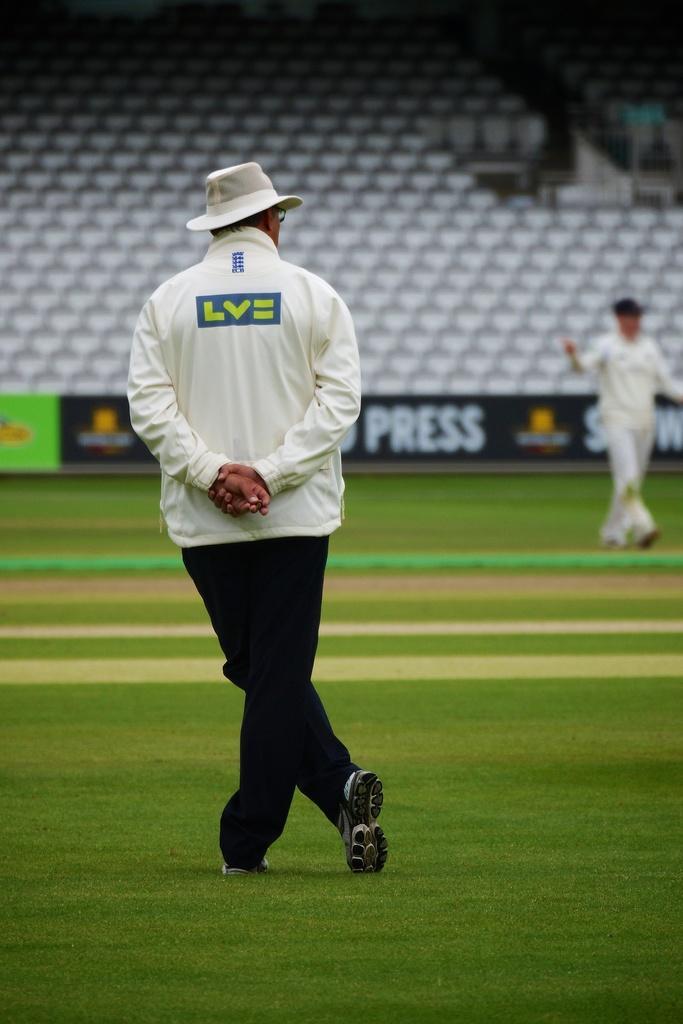Could you give a brief overview of what you see in this image? In this image we can see there is an inside view of the stadium and there are chairs and the wall with a banner. And there are two people standing on the ground. 